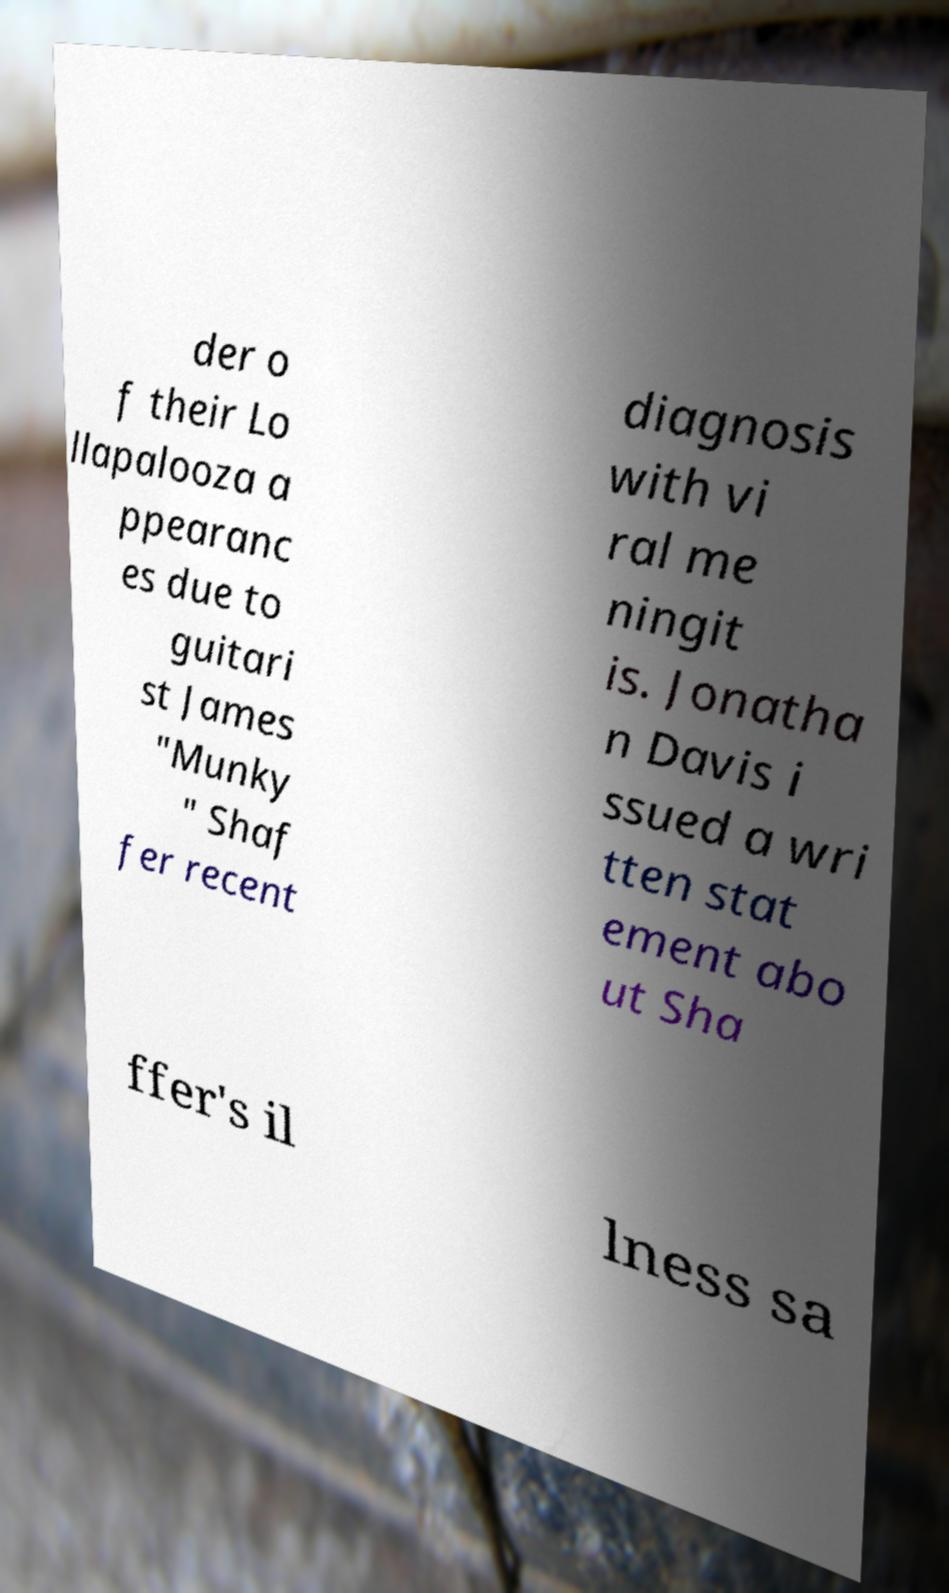Please read and relay the text visible in this image. What does it say? der o f their Lo llapalooza a ppearanc es due to guitari st James "Munky " Shaf fer recent diagnosis with vi ral me ningit is. Jonatha n Davis i ssued a wri tten stat ement abo ut Sha ffer's il lness sa 